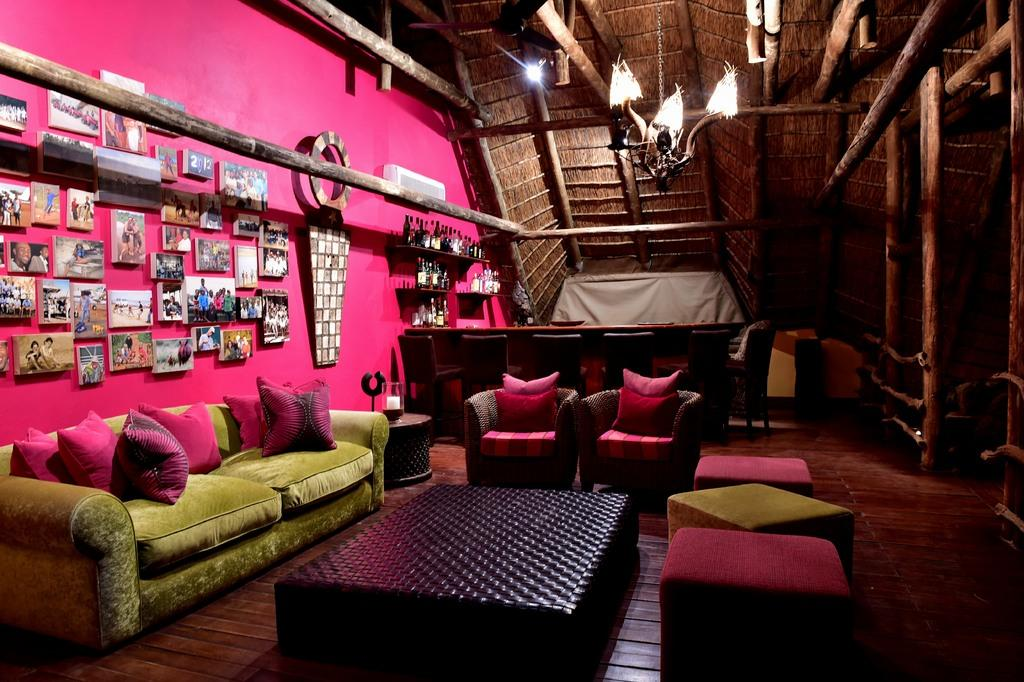What type of furniture is present in the image? There are sofas and chairs in the image. What color is the table in the image? The table in the image is black. Where are the pictures located in the image? The pictures are on a pink wall in the image. What type of lift is present in the image? There is no lift present in the image. What type of teeth can be seen in the image? There are no teeth visible in the image. 